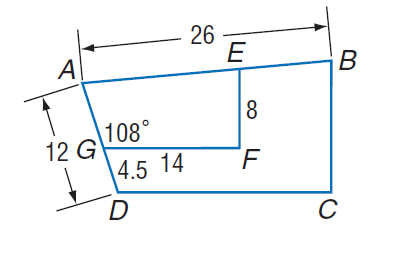Answer the mathemtical geometry problem and directly provide the correct option letter.
Question: Polygon A B C D \sim polygon A E F G, m \angle A G F = 108, G F = 14, A D = 12, D G = 4.5, E F = 8, and A B = 26. Find D C.
Choices: A: 12 B: 14 C: 22.4 D: 26 C 